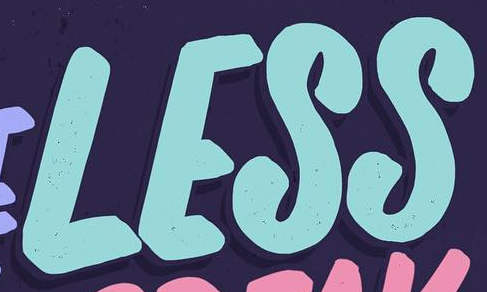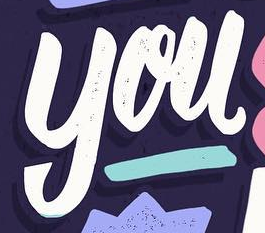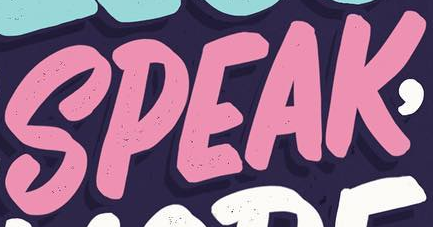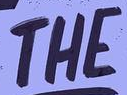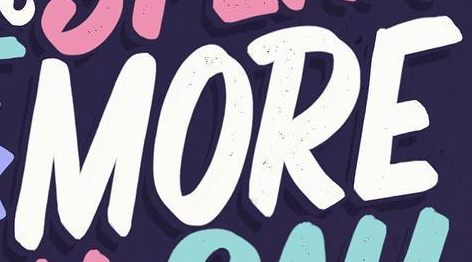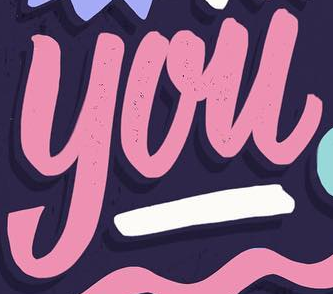Read the text from these images in sequence, separated by a semicolon. LESS; you; SPEAK; THE; MORE; you 